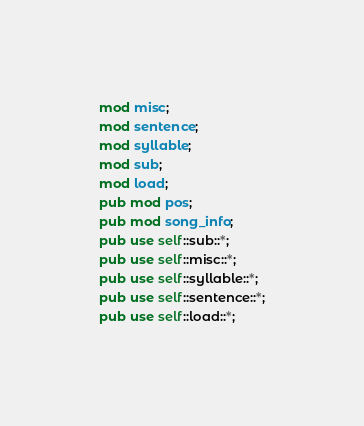Convert code to text. <code><loc_0><loc_0><loc_500><loc_500><_Rust_>mod misc;
mod sentence;
mod syllable;
mod sub;
mod load;
pub mod pos;
pub mod song_info;
pub use self::sub::*;
pub use self::misc::*;
pub use self::syllable::*;
pub use self::sentence::*;
pub use self::load::*;
</code> 